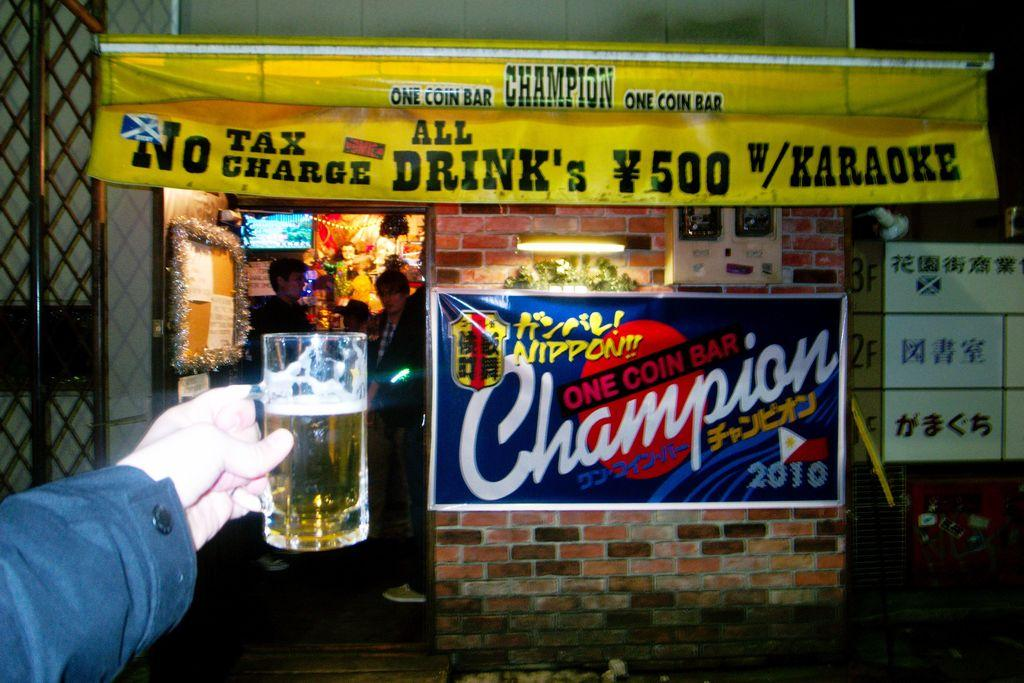<image>
Describe the image concisely. A person holding a beer in front of an All drink's no tax charge sign. 